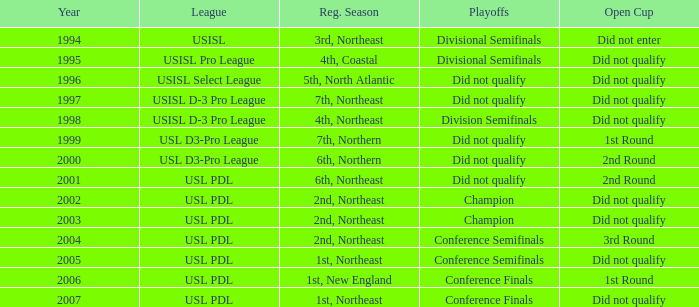Specify the championship series for the usisl select league. Did not qualify. 